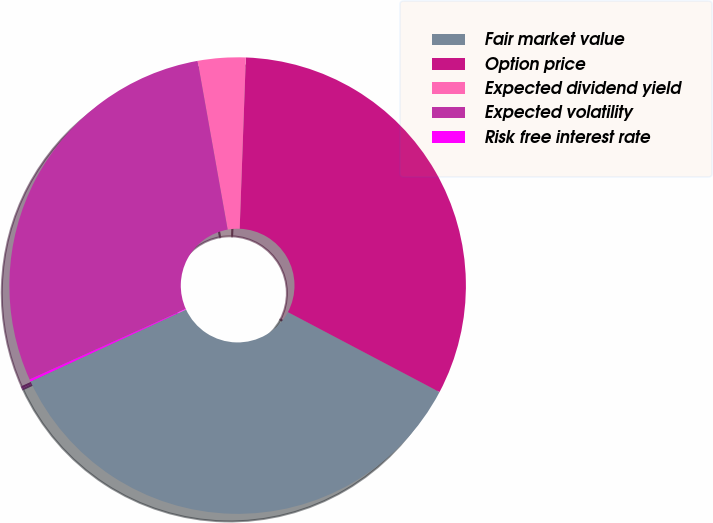Convert chart. <chart><loc_0><loc_0><loc_500><loc_500><pie_chart><fcel>Fair market value<fcel>Option price<fcel>Expected dividend yield<fcel>Expected volatility<fcel>Risk free interest rate<nl><fcel>35.37%<fcel>32.15%<fcel>3.38%<fcel>28.94%<fcel>0.16%<nl></chart> 